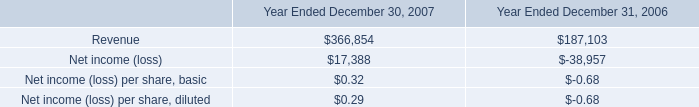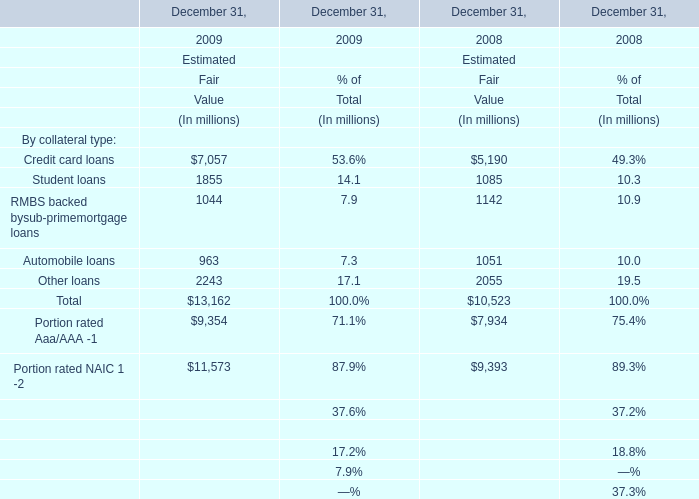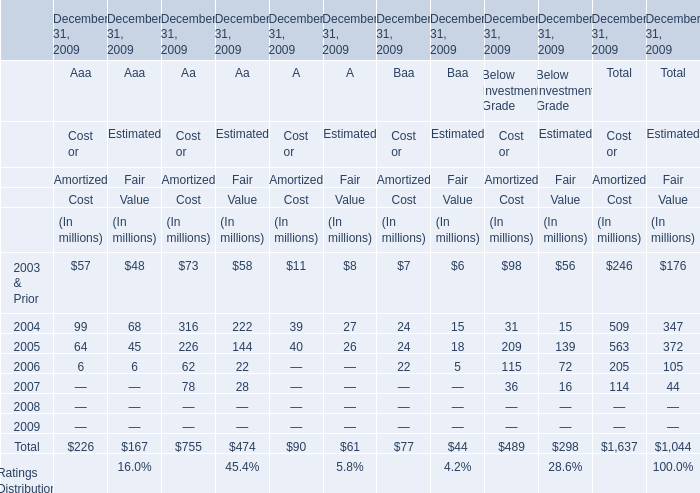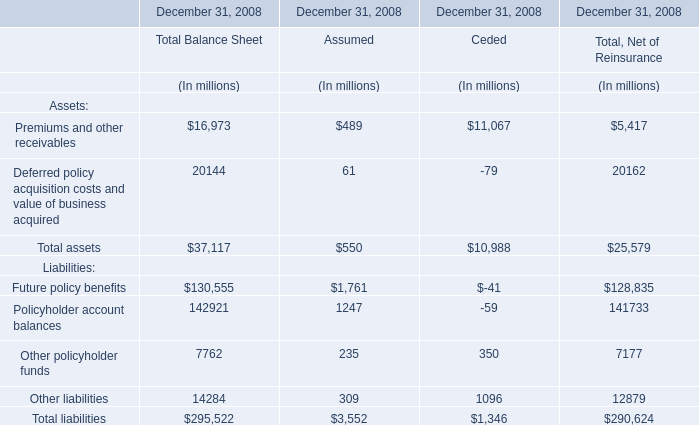What's the Estimated Fair Value for Automobile loans in the year where the Estimated Fair Value for Other loans is greater than 2200 million? (in million) 
Answer: 963. 